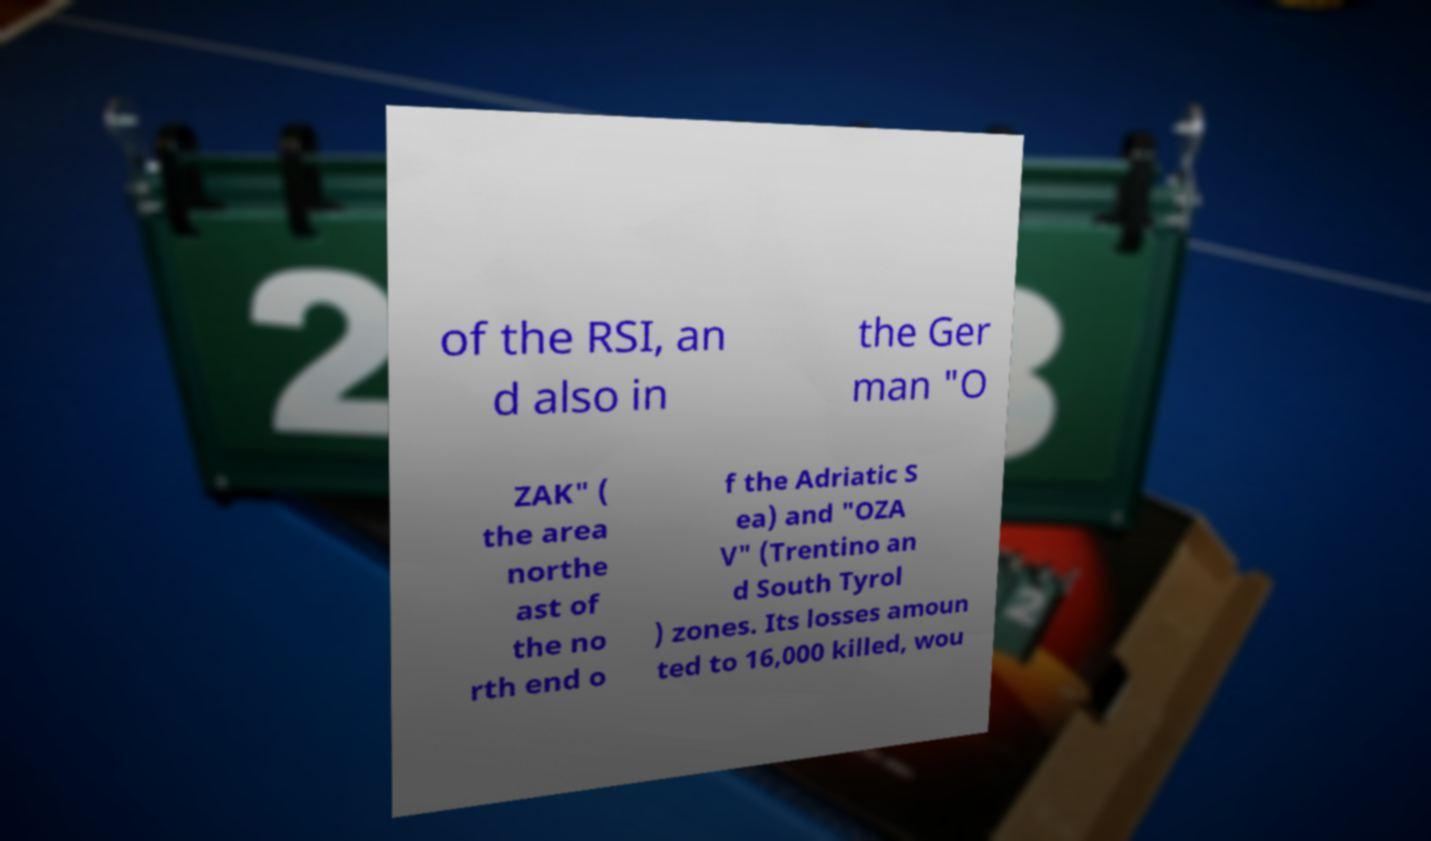Please read and relay the text visible in this image. What does it say? of the RSI, an d also in the Ger man "O ZAK" ( the area northe ast of the no rth end o f the Adriatic S ea) and "OZA V" (Trentino an d South Tyrol ) zones. Its losses amoun ted to 16,000 killed, wou 